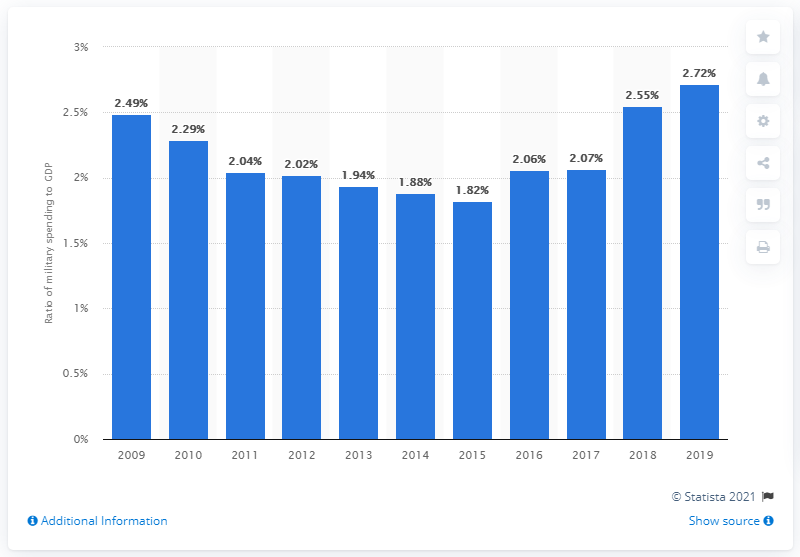Point out several critical features in this image. In 2019, military expenditure accounted for approximately 2.72% of Turkey's gross domestic product. 